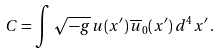<formula> <loc_0><loc_0><loc_500><loc_500>C = \int \sqrt { - g } \, u ( x ^ { \prime } ) \, \overline { u } _ { 0 } ( x ^ { \prime } ) \, d ^ { 4 } x ^ { \prime } \, .</formula> 